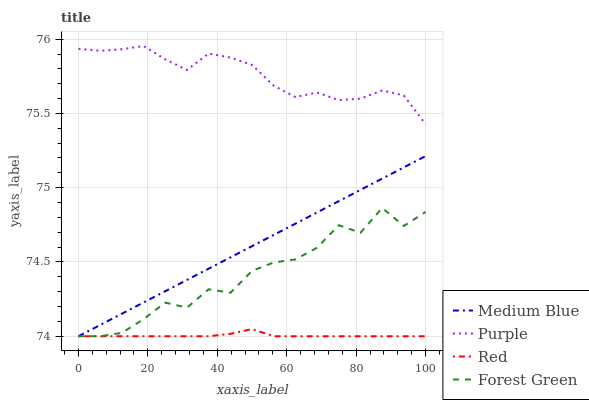Does Red have the minimum area under the curve?
Answer yes or no. Yes. Does Purple have the maximum area under the curve?
Answer yes or no. Yes. Does Forest Green have the minimum area under the curve?
Answer yes or no. No. Does Forest Green have the maximum area under the curve?
Answer yes or no. No. Is Medium Blue the smoothest?
Answer yes or no. Yes. Is Forest Green the roughest?
Answer yes or no. Yes. Is Forest Green the smoothest?
Answer yes or no. No. Is Medium Blue the roughest?
Answer yes or no. No. Does Forest Green have the lowest value?
Answer yes or no. Yes. Does Purple have the highest value?
Answer yes or no. Yes. Does Forest Green have the highest value?
Answer yes or no. No. Is Medium Blue less than Purple?
Answer yes or no. Yes. Is Purple greater than Red?
Answer yes or no. Yes. Does Medium Blue intersect Red?
Answer yes or no. Yes. Is Medium Blue less than Red?
Answer yes or no. No. Is Medium Blue greater than Red?
Answer yes or no. No. Does Medium Blue intersect Purple?
Answer yes or no. No. 